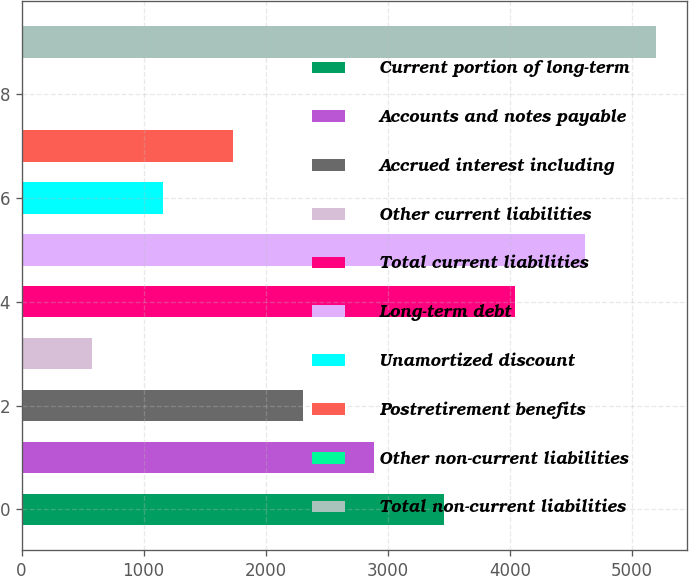Convert chart. <chart><loc_0><loc_0><loc_500><loc_500><bar_chart><fcel>Current portion of long-term<fcel>Accounts and notes payable<fcel>Accrued interest including<fcel>Other current liabilities<fcel>Total current liabilities<fcel>Long-term debt<fcel>Unamortized discount<fcel>Postretirement benefits<fcel>Other non-current liabilities<fcel>Total non-current liabilities<nl><fcel>3463.4<fcel>2886.5<fcel>2309.6<fcel>578.9<fcel>4040.3<fcel>4617.2<fcel>1155.8<fcel>1732.7<fcel>2<fcel>5194.1<nl></chart> 